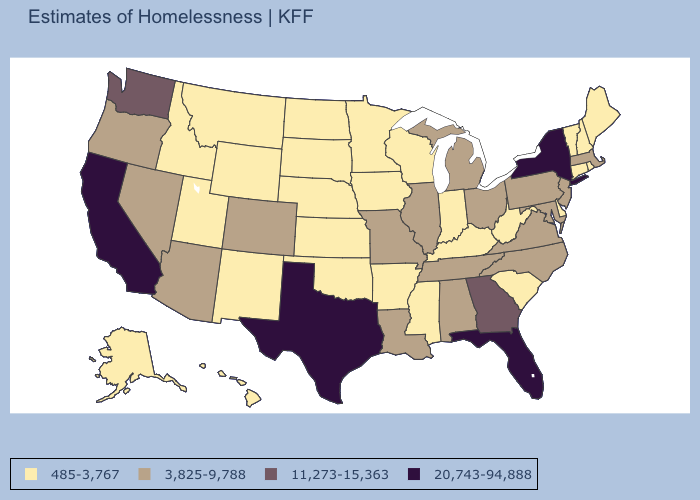Among the states that border Kentucky , which have the lowest value?
Be succinct. Indiana, West Virginia. Which states have the lowest value in the USA?
Write a very short answer. Alaska, Arkansas, Connecticut, Delaware, Hawaii, Idaho, Indiana, Iowa, Kansas, Kentucky, Maine, Minnesota, Mississippi, Montana, Nebraska, New Hampshire, New Mexico, North Dakota, Oklahoma, Rhode Island, South Carolina, South Dakota, Utah, Vermont, West Virginia, Wisconsin, Wyoming. What is the value of Vermont?
Give a very brief answer. 485-3,767. What is the value of Wisconsin?
Answer briefly. 485-3,767. What is the value of Montana?
Keep it brief. 485-3,767. What is the value of Delaware?
Concise answer only. 485-3,767. What is the value of Missouri?
Concise answer only. 3,825-9,788. What is the value of Virginia?
Answer briefly. 3,825-9,788. Which states have the lowest value in the USA?
Concise answer only. Alaska, Arkansas, Connecticut, Delaware, Hawaii, Idaho, Indiana, Iowa, Kansas, Kentucky, Maine, Minnesota, Mississippi, Montana, Nebraska, New Hampshire, New Mexico, North Dakota, Oklahoma, Rhode Island, South Carolina, South Dakota, Utah, Vermont, West Virginia, Wisconsin, Wyoming. Name the states that have a value in the range 485-3,767?
Answer briefly. Alaska, Arkansas, Connecticut, Delaware, Hawaii, Idaho, Indiana, Iowa, Kansas, Kentucky, Maine, Minnesota, Mississippi, Montana, Nebraska, New Hampshire, New Mexico, North Dakota, Oklahoma, Rhode Island, South Carolina, South Dakota, Utah, Vermont, West Virginia, Wisconsin, Wyoming. Among the states that border Tennessee , which have the lowest value?
Quick response, please. Arkansas, Kentucky, Mississippi. Name the states that have a value in the range 20,743-94,888?
Short answer required. California, Florida, New York, Texas. What is the highest value in states that border South Carolina?
Answer briefly. 11,273-15,363. Name the states that have a value in the range 485-3,767?
Be succinct. Alaska, Arkansas, Connecticut, Delaware, Hawaii, Idaho, Indiana, Iowa, Kansas, Kentucky, Maine, Minnesota, Mississippi, Montana, Nebraska, New Hampshire, New Mexico, North Dakota, Oklahoma, Rhode Island, South Carolina, South Dakota, Utah, Vermont, West Virginia, Wisconsin, Wyoming. 